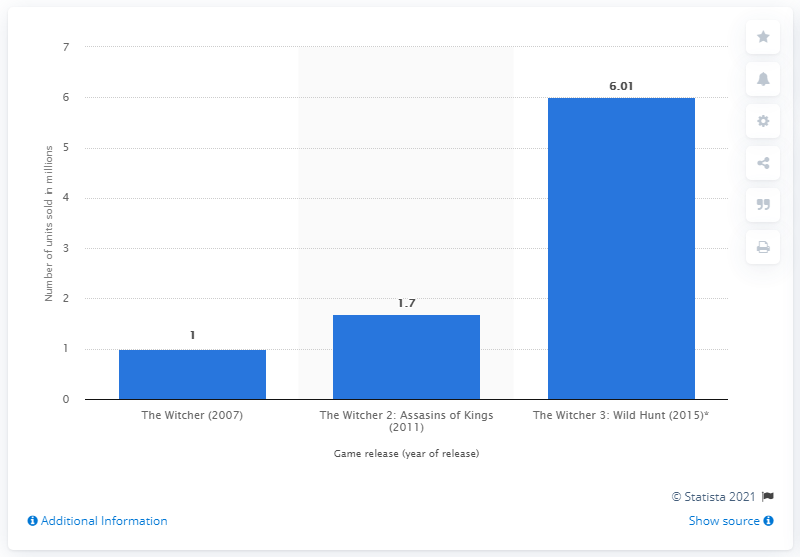Indicate a few pertinent items in this graphic. The third part of The Witcher series had already sold 6.01 units as of now. 